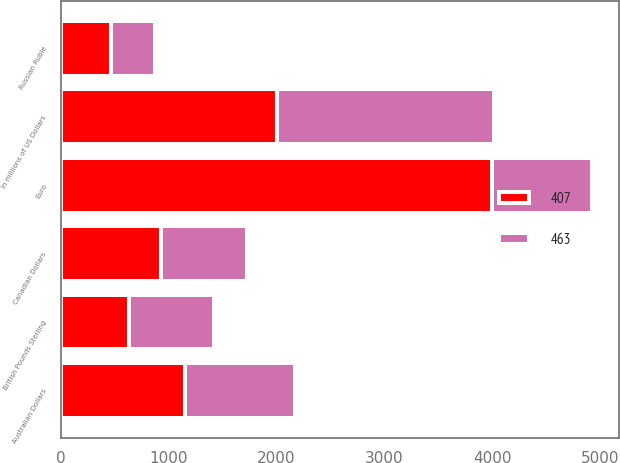<chart> <loc_0><loc_0><loc_500><loc_500><stacked_bar_chart><ecel><fcel>In millions of US Dollars<fcel>Euro<fcel>Australian Dollars<fcel>Canadian Dollars<fcel>British Pounds Sterling<fcel>Russian Ruble<nl><fcel>463<fcel>2008<fcel>929<fcel>1023<fcel>795<fcel>785<fcel>407<nl><fcel>407<fcel>2007<fcel>3999<fcel>1147<fcel>929<fcel>634<fcel>463<nl></chart> 